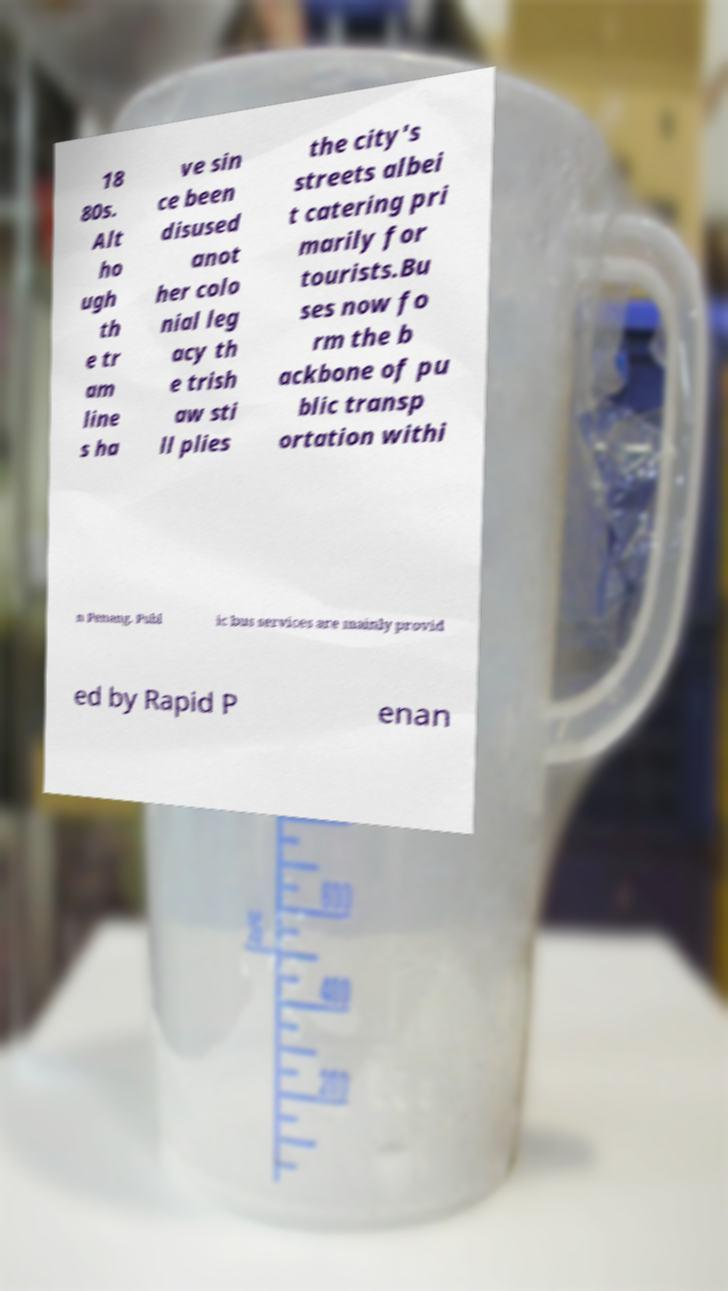Could you assist in decoding the text presented in this image and type it out clearly? 18 80s. Alt ho ugh th e tr am line s ha ve sin ce been disused anot her colo nial leg acy th e trish aw sti ll plies the city's streets albei t catering pri marily for tourists.Bu ses now fo rm the b ackbone of pu blic transp ortation withi n Penang. Publ ic bus services are mainly provid ed by Rapid P enan 